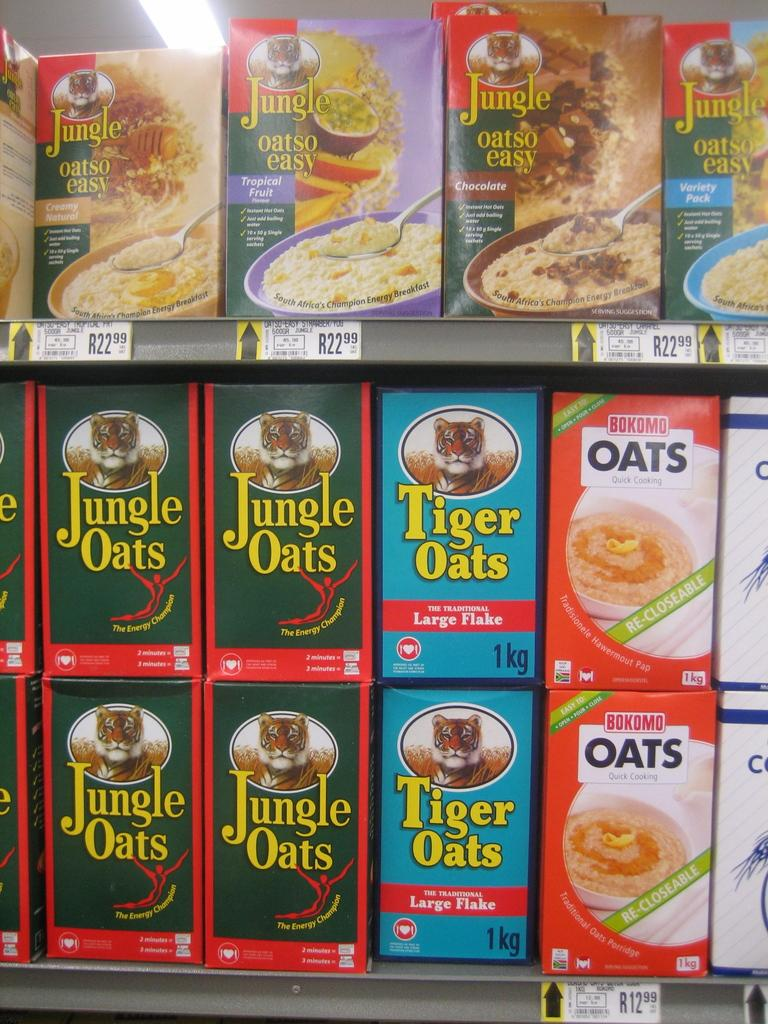What objects are present in the image? There are boxes in the image. What can be seen on the boxes? The boxes have text and images on them. Where is the light located in the image? The light is on the top of the image. What type of pickle is being used as a toy in the image? There is no pickle or toy present in the image; it only features boxes with text and images. 